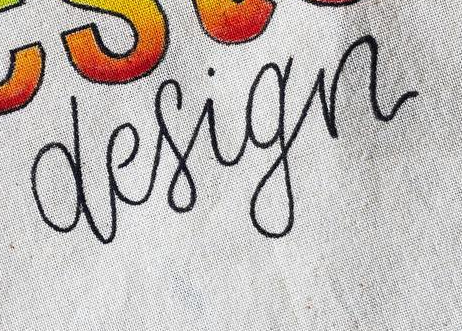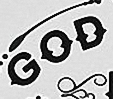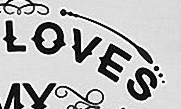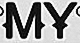What text appears in these images from left to right, separated by a semicolon? design; GOD; LOVES; MY 